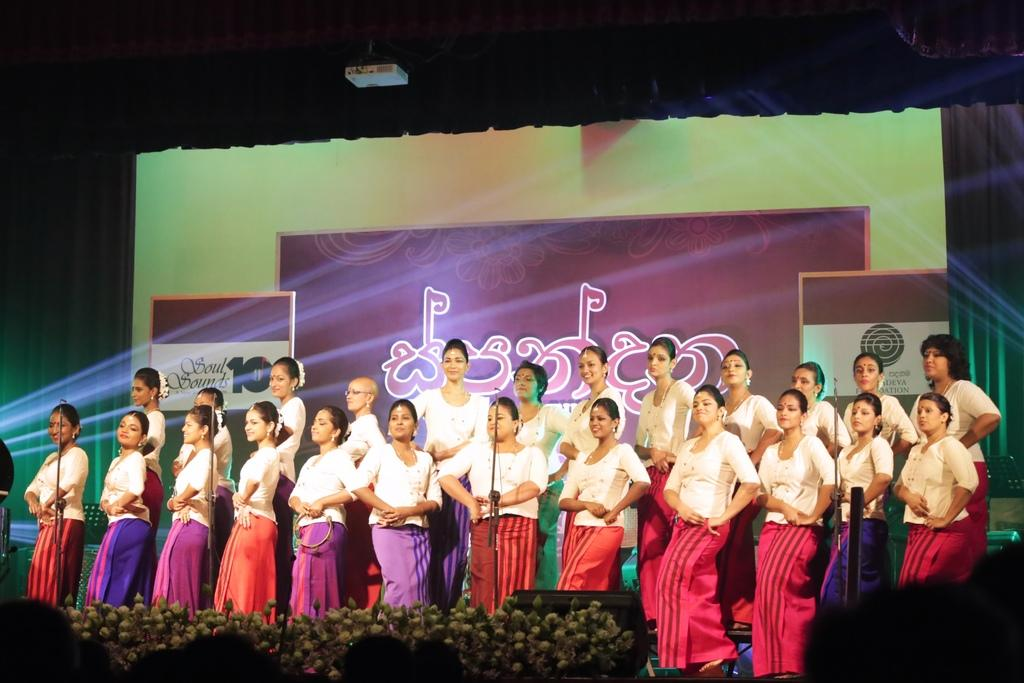Who or what is present in the image? There are people in the image. What are the people wearing? The people are wearing white tops. What else can be seen in the image besides the people? There is a screen visible in the image. Can you see any worms crawling on the screen in the image? There are no worms visible in the image, as the focus is on the people and their white tops. 